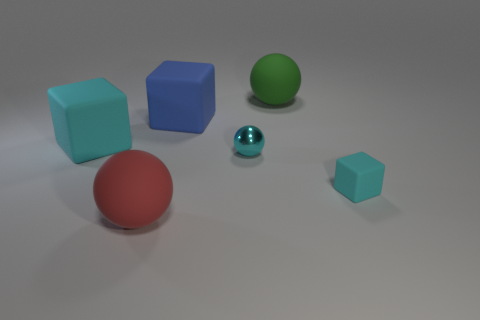There is a matte object in front of the small cyan rubber cube; is its color the same as the shiny ball?
Your answer should be compact. No. What is the size of the cyan ball?
Your response must be concise. Small. What size is the blue block behind the tiny thing on the right side of the cyan metal sphere?
Offer a terse response. Large. What number of things are the same color as the small shiny ball?
Offer a terse response. 2. How many spheres are there?
Make the answer very short. 3. How many tiny balls have the same material as the green object?
Your answer should be compact. 0. There is a green matte thing that is the same shape as the tiny cyan metallic thing; what size is it?
Keep it short and to the point. Large. What is the material of the small cube?
Give a very brief answer. Rubber. There is a large sphere behind the cyan rubber thing to the left of the small cyan metal thing that is right of the blue cube; what is its material?
Ensure brevity in your answer.  Rubber. Is there any other thing that is the same shape as the green matte thing?
Give a very brief answer. Yes. 